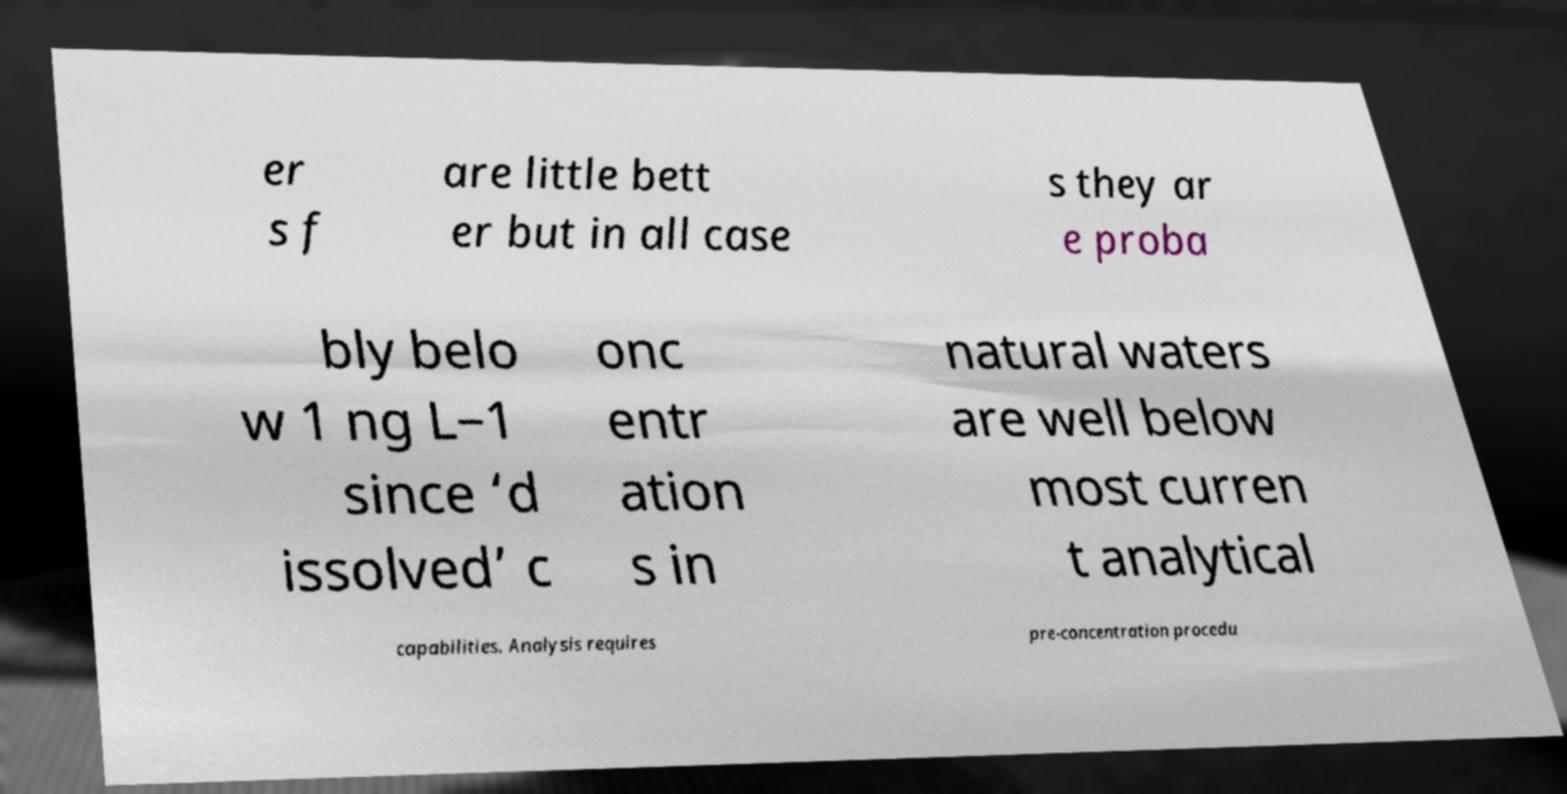For documentation purposes, I need the text within this image transcribed. Could you provide that? er s f are little bett er but in all case s they ar e proba bly belo w 1 ng L−1 since ‘d issolved’ c onc entr ation s in natural waters are well below most curren t analytical capabilities. Analysis requires pre-concentration procedu 